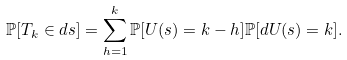<formula> <loc_0><loc_0><loc_500><loc_500>\mathbb { P } [ T _ { k } \in d s ] = \sum _ { h = 1 } ^ { k } \mathbb { P } [ U ( s ) = k - h ] \mathbb { P } [ d U ( s ) = k ] .</formula> 